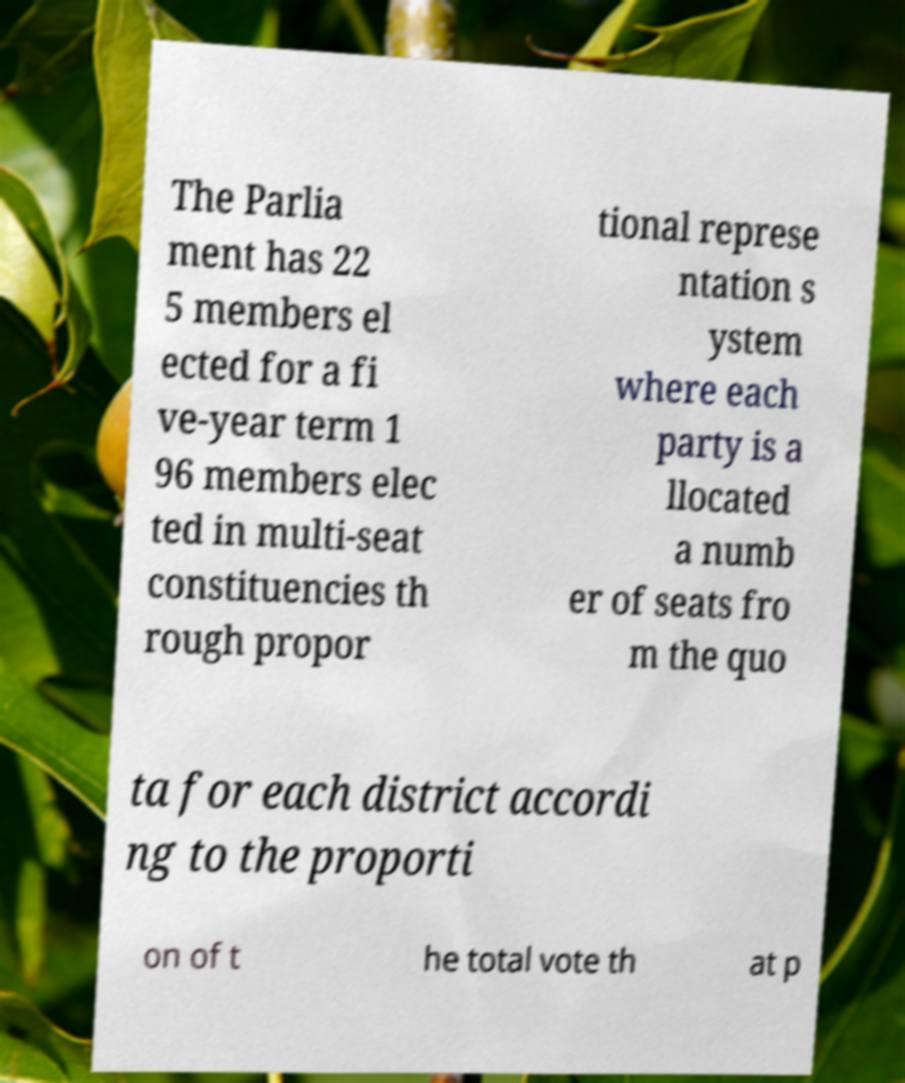For documentation purposes, I need the text within this image transcribed. Could you provide that? The Parlia ment has 22 5 members el ected for a fi ve-year term 1 96 members elec ted in multi-seat constituencies th rough propor tional represe ntation s ystem where each party is a llocated a numb er of seats fro m the quo ta for each district accordi ng to the proporti on of t he total vote th at p 